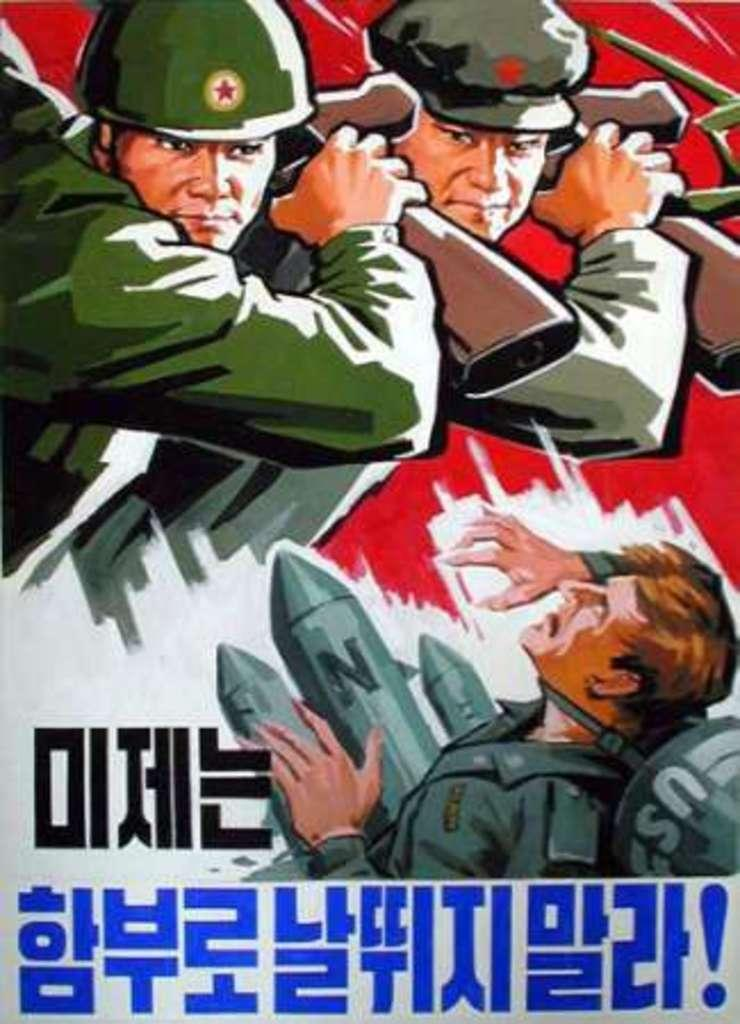What is the main subject of the image? There is a poster in the image. What can be seen on the poster? The poster contains images of people. What are the people in the poster doing? Some people in the poster are holding objects. Is there any text on the poster? Yes, there is text on the poster. Can you see any worms crawling on the poster in the image? There are no worms present on the poster in the image. What type of board is featured in the poster? There is no board featured in the poster; it contains images of people holding objects. 